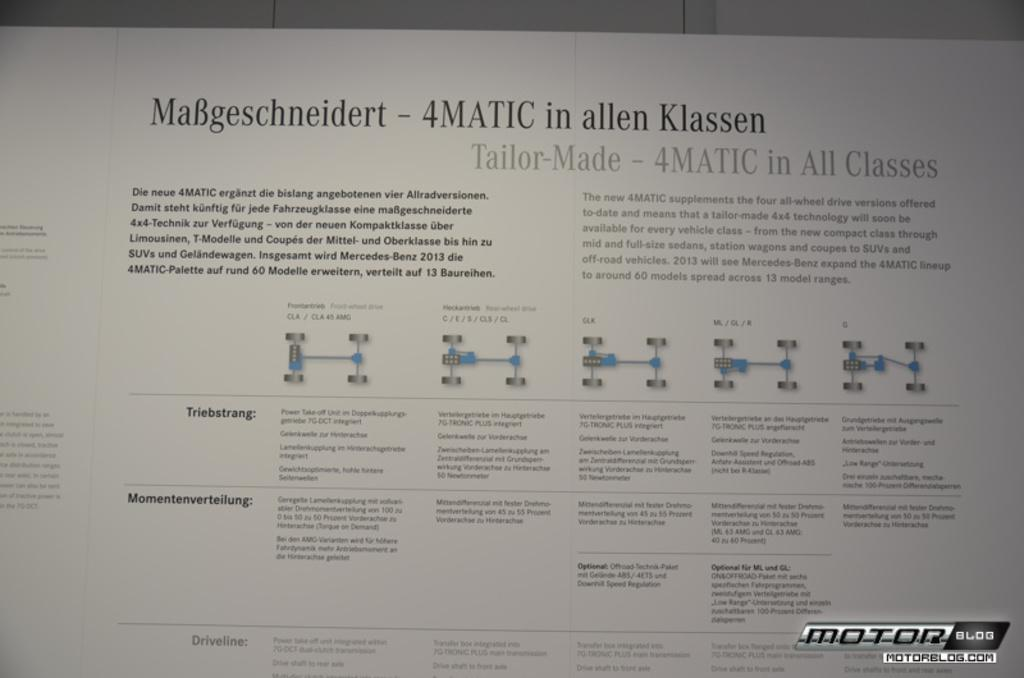What is the main object in the image? There is a white descriptive board in the image. Can you describe the text at the bottom of the image? Yes, there is text at the bottom of the image. How much liquid is present on the string in the image? There is no liquid or string present in the image. 